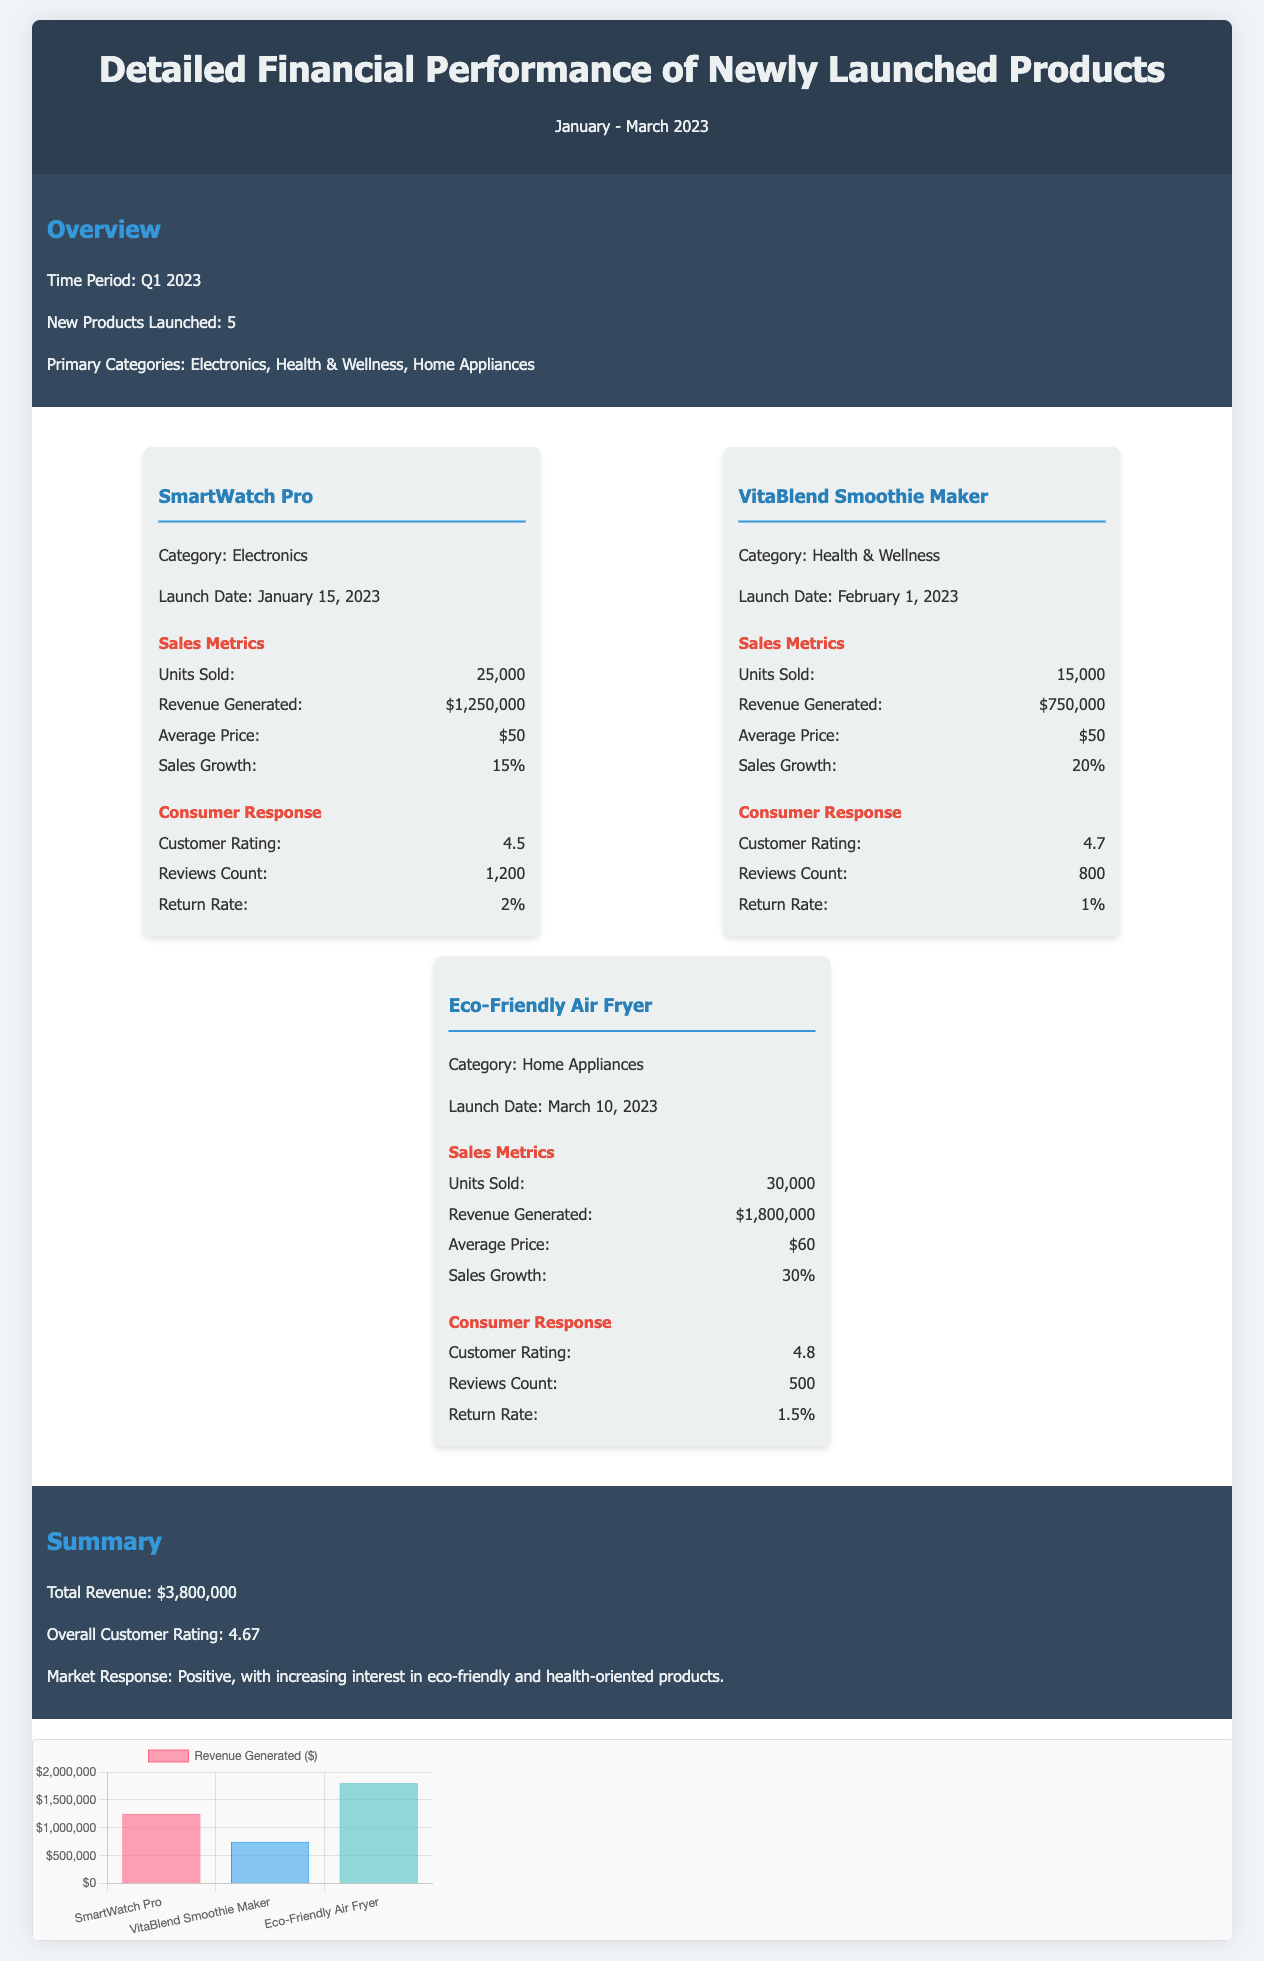what is the launch date of SmartWatch Pro? The launch date of SmartWatch Pro is specifically mentioned in the document.
Answer: January 15, 2023 how many units of VitaBlend Smoothie Maker were sold? The document provides the number of units sold for each product, including VitaBlend Smoothie Maker.
Answer: 15,000 what is the customer rating of Eco-Friendly Air Fryer? The document lists the customer rating for Eco-Friendly Air Fryer under consumer response data.
Answer: 4.8 what category does the VitaBlend Smoothie Maker belong to? The document categorizes each product, and VitaBlend Smoothie Maker is included.
Answer: Health & Wellness what is the total revenue generated from all new products? The total revenue is summarized in the document, derived from the revenue generated by each product.
Answer: $3,800,000 what percentage is the sales growth of the SmartWatch Pro? The document shows the sales growth percentage for each new product, including SmartWatch Pro.
Answer: 15% which product had the highest revenue generated? The document lists the revenue generated for each product, allowing for a comparison to determine which had the highest.
Answer: Eco-Friendly Air Fryer what is the overall customer rating for all products combined? The document provides a summary of the overall customer rating for all new products.
Answer: 4.67 